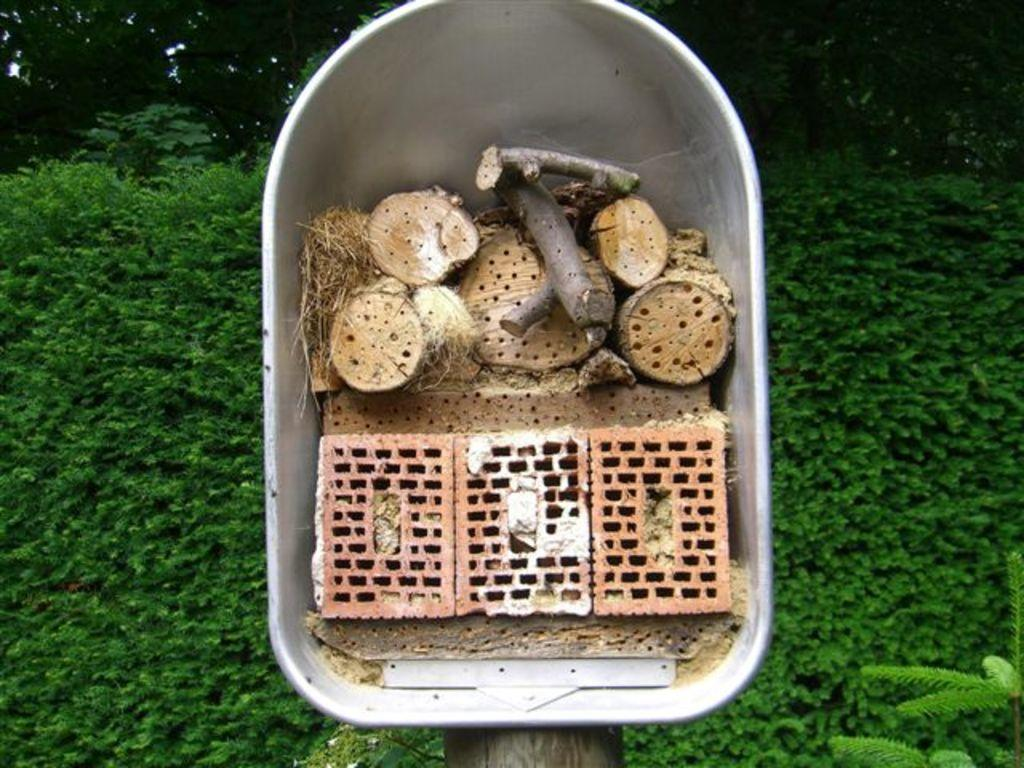What is the color of the box in the image? The box in the image is silver in color. What is inside the box? The box contains wooden pieces. What can be seen behind the box? There is a plant behind the box, and trees are visible behind the box at the top of the image. How does the letter affect the health of the beam in the image? There is no letter or beam present in the image, so this question cannot be answered. 